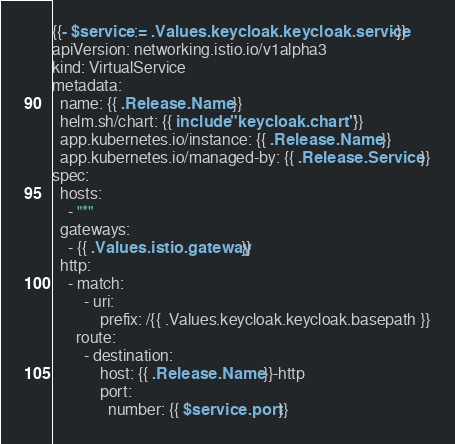<code> <loc_0><loc_0><loc_500><loc_500><_YAML_>{{- $service := .Values.keycloak.keycloak.service -}}
apiVersion: networking.istio.io/v1alpha3
kind: VirtualService
metadata:
  name: {{ .Release.Name }}
  helm.sh/chart: {{ include "keycloak.chart" . }}
  app.kubernetes.io/instance: {{ .Release.Name }}
  app.kubernetes.io/managed-by: {{ .Release.Service }}
spec:
  hosts:
    - "*"
  gateways:
    - {{ .Values.istio.gateway }}
  http:
    - match:
        - uri:
            prefix: /{{ .Values.keycloak.keycloak.basepath }}
      route:
        - destination:
            host: {{ .Release.Name }}-http
            port:
              number: {{ $service.port }}
</code> 